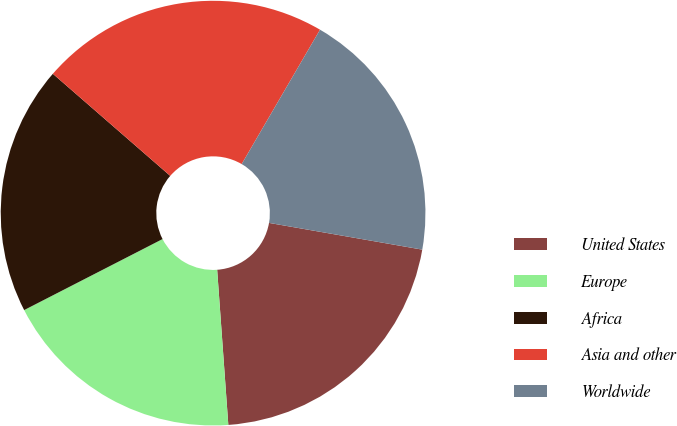<chart> <loc_0><loc_0><loc_500><loc_500><pie_chart><fcel>United States<fcel>Europe<fcel>Africa<fcel>Asia and other<fcel>Worldwide<nl><fcel>21.11%<fcel>18.6%<fcel>18.94%<fcel>22.01%<fcel>19.35%<nl></chart> 